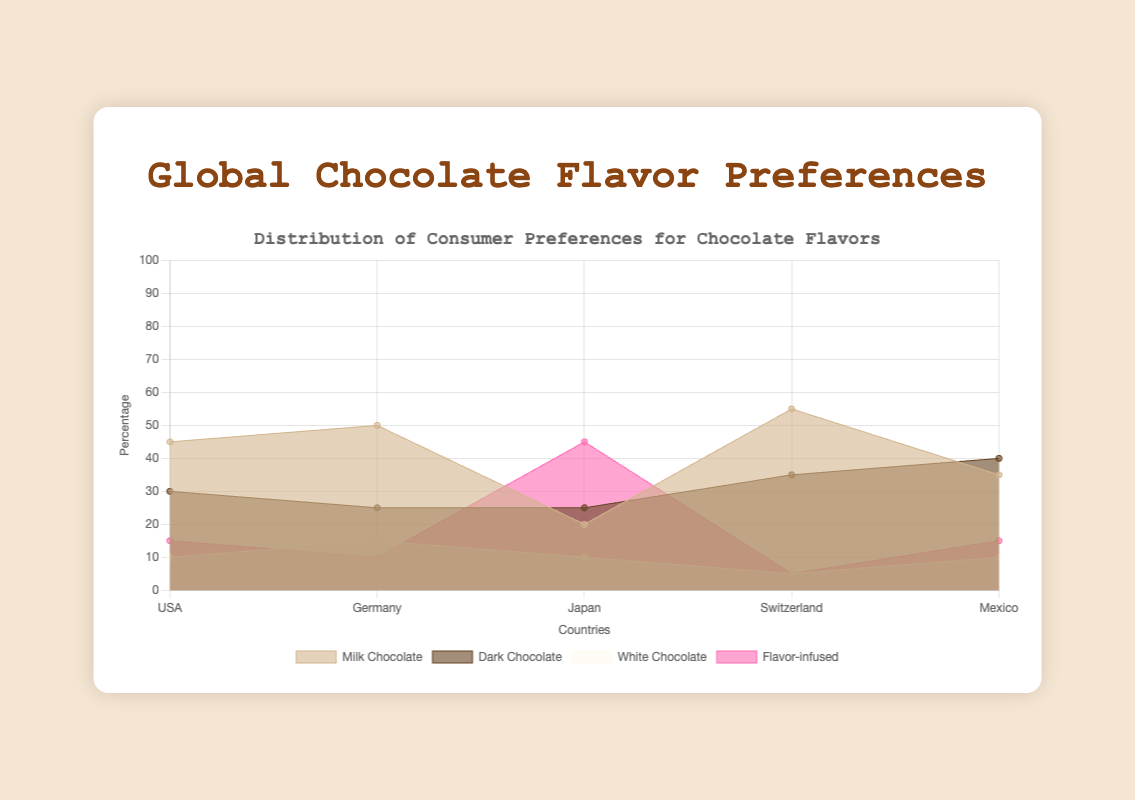How many countries are represented in the figure? Count the distinct countries listed along the x-axis of the figure.
Answer: 5 Which country has the highest preference for Milk Chocolate? Identify the country with the tallest area in the color representing Milk Chocolate (light brown).
Answer: Switzerland What is the combined percentage preference for Dark Chocolate and Flavor-infused chocolate in Japan? Add the percentages of Dark Chocolate (25%) and Flavor-infused chocolate (45%) for Japan.
Answer: 70% Which country shows the least preference for White Chocolate? Look for the country with the smallest area representing White Chocolate (off-white).
Answer: Switzerland Compare the preference for Dark Chocolate between Mexico and Germany. Which country has a higher preference? Find the Dark Chocolate percentages for both countries (Mexico: 40%, Germany: 25%). Mexico has a higher preference.
Answer: Mexico What is the total preference percentage for all flavors in the USA? Sum the percentages of all flavors for the USA (45% + 30% + 10% + 15%).
Answer: 100% Which flavor is least preferred in Switzerland? Identify the smallest area for each flavor in Switzerland.
Answer: White Chocolate Between the USA and Japan, which country has a higher preference for Milk Chocolate? Compare the Milk Chocolate preference percentages of both countries (USA: 45%, Japan: 20%). USA has a higher preference.
Answer: USA In which country is Flavor-infused chocolate the most popular? Identify the country with the highest percentage for Flavor-infused chocolate.
Answer: Japan What is the difference in preference for Dark Chocolate between Switzerland and the USA? Subtract the percentage of Dark Chocolate in the USA (30%) from that in Switzerland (35%).
Answer: 5% 